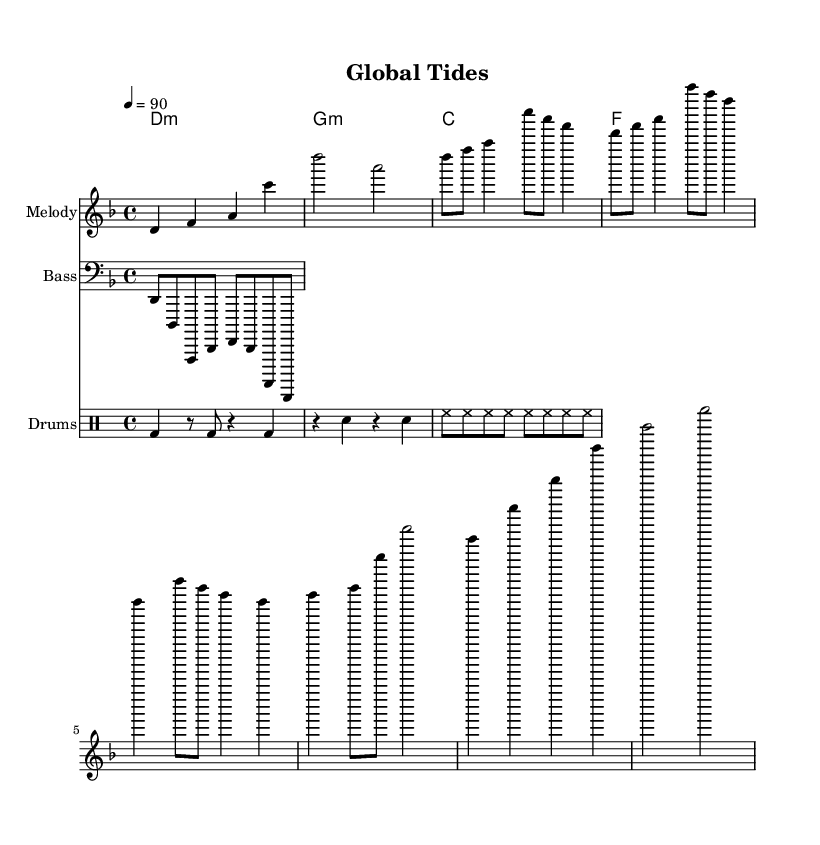What is the key signature of this music? The key signature is indicated by the key signature signature for D minor. It has one flat, which corresponds to B flat.
Answer: D minor What is the time signature of this piece? The time signature is represented at the beginning of the score as 4/4, meaning there are four beats in each measure and the quarter note gets one beat.
Answer: 4/4 What is the tempo marking for this piece? The tempo marking is shown as ♩ = 90, indicating that there are 90 beats per minute, and this will dictate the speed of the performance.
Answer: 90 How many measures are there in the chorus section? To determine this, look for the section labeled as the chorus; it consists of two measures for the chorus. This can be visible through the notation structure within the score.
Answer: 2 What type of bass clef is used in this piece? The clef symbol is present before the bass line, indicating lower pitch range and is specifically the bass clef, or F clef, which allows for the notation of low notes.
Answer: Bass clef How many notes are played in the main melody? The melody consists of several notes across different measures; upon counting the distinct note values in the melody part, there are a total of 15 notes played.
Answer: 15 